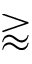<formula> <loc_0><loc_0><loc_500><loc_500>\gtrapprox</formula> 